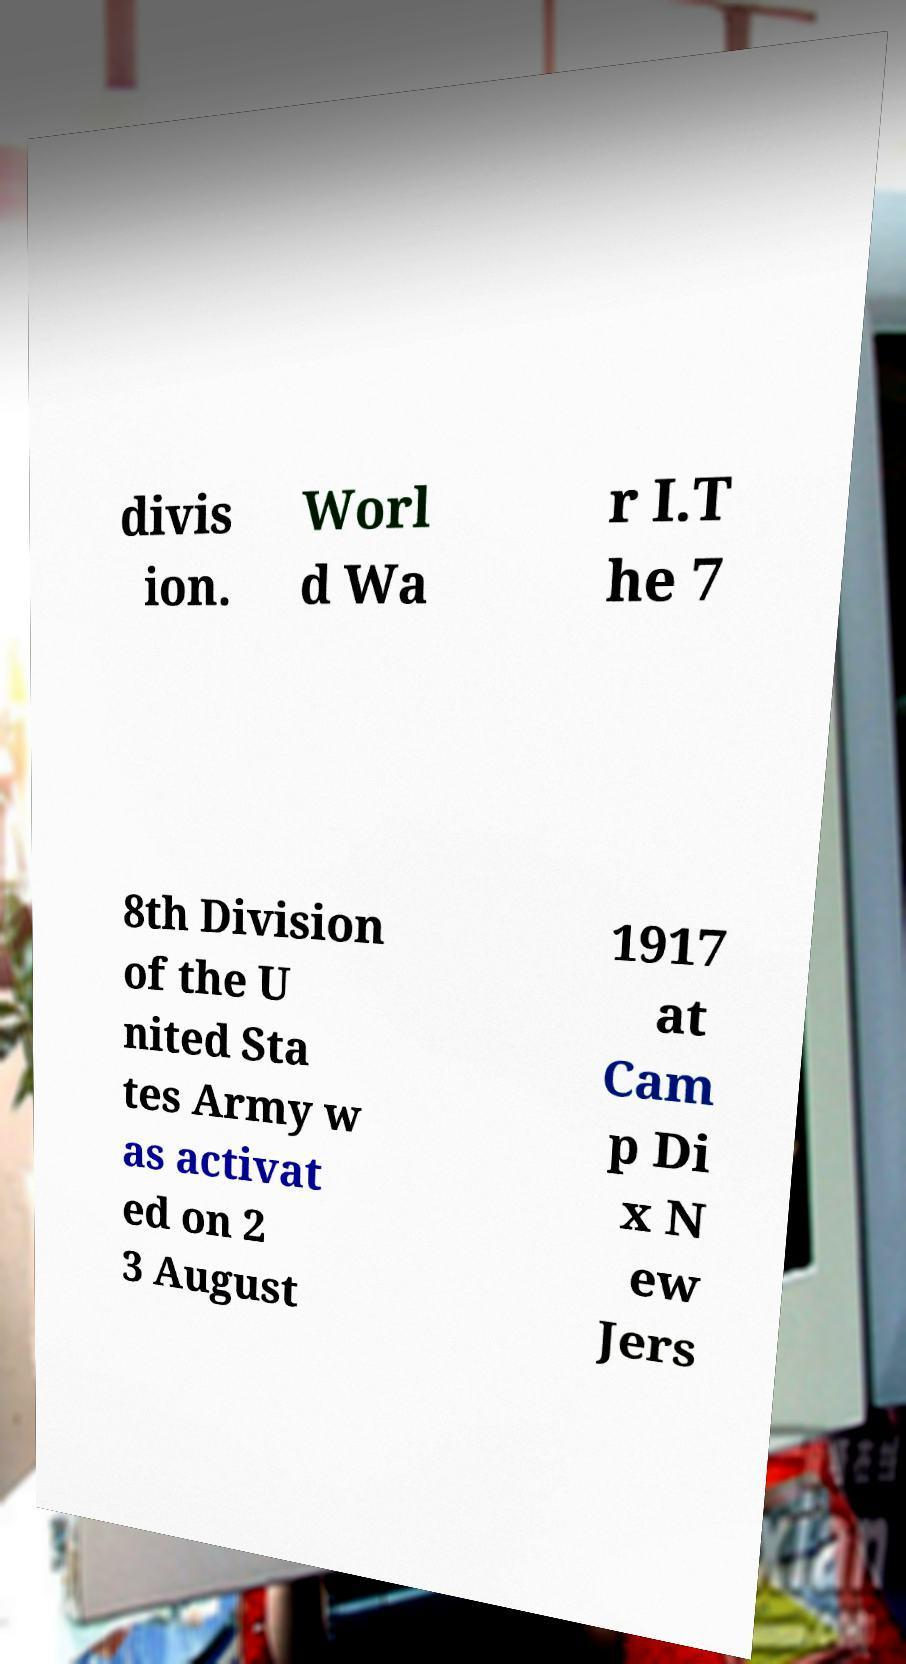Please identify and transcribe the text found in this image. divis ion. Worl d Wa r I.T he 7 8th Division of the U nited Sta tes Army w as activat ed on 2 3 August 1917 at Cam p Di x N ew Jers 